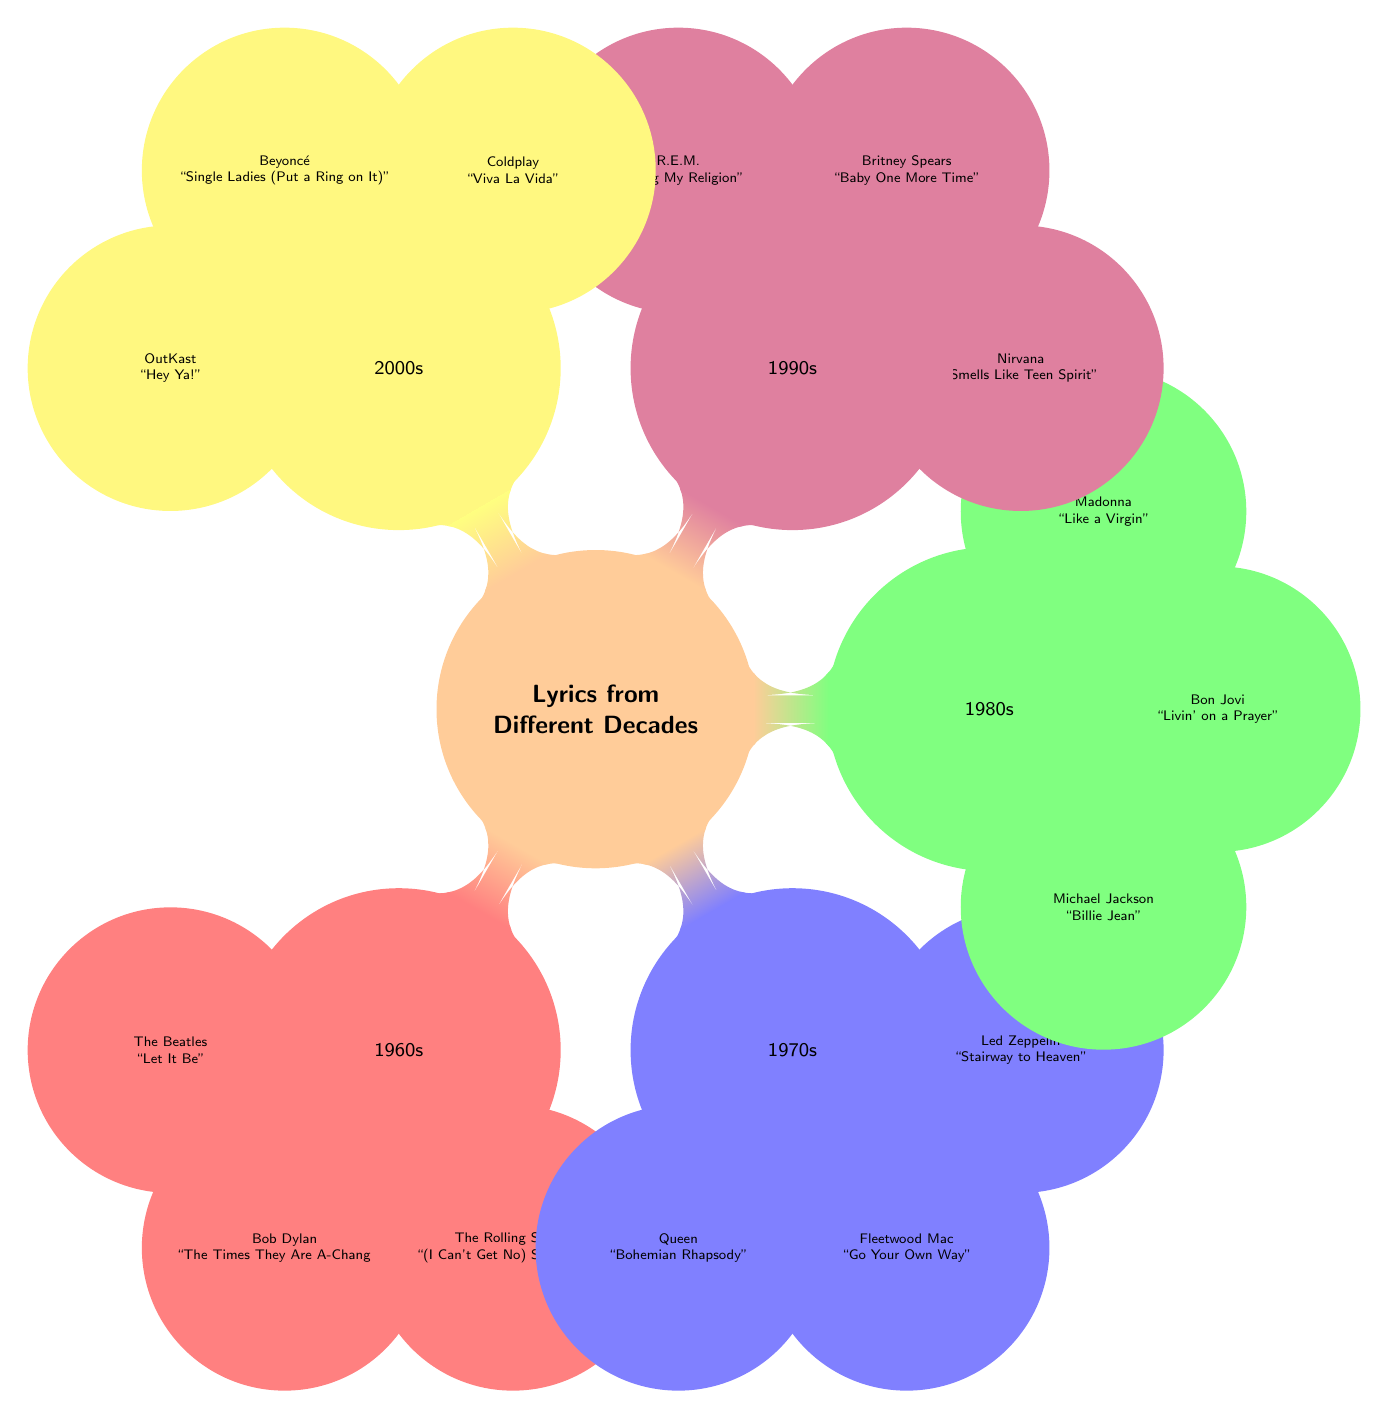What decade features "Billie Jean" by Michael Jackson? The diagram indicates that "Billie Jean" by Michael Jackson is located under the 1980s node. Therefore, the answer corresponds to that decade.
Answer: 1980s Which song by The Beatles is mentioned? The diagram lists “Let It Be” as the song by The Beatles under the 1960s node. Therefore, it directly identifies the song referenced.
Answer: Let It Be How many songs are listed under the 1990s? By counting the child nodes under the 1990s node in the diagram, we see there are three songs listed. Thus, the answer reflects this count.
Answer: 3 What genre does "Hey Ya!" belong to? "Hey Ya!" is listed as one of the songs under the 2000s node. While the diagram does not explicitly state the genre, it is widely known as a hip-hop song, which is inferred from the categorical grouping.
Answer: Hip-hop Which song includes the lyric "If you liked it, then you shoulda put a ring on it"? The diagram indicates that this lyric comes from Beyoncé's song "Single Ladies (Put a Ring on It)" listed under the 2000s node. Therefore, the song title can be directly traced to the lyric mentioned.
Answer: Single Ladies (Put a Ring on It) What is the common theme of the songs listed in the 1970s? While the diagram does not explicitly outline a common theme, by reviewing the song titles and understanding the cultural context of the era, we can deduce that the theme tends to revolve around personal and emotional experiences, typical of the 1970s music.
Answer: Personal and emotional experiences Which decade has "Smells Like Teen Spirit"? From the diagram, "Smells Like Teen Spirit" is identified under the 1990s node, directing us to the specific decade associated with the song.
Answer: 1990s How many decades are represented in the diagram? The diagram displays five distinct decades, each represented as a top-level node. Thus, the answer reflects the number of decades shown in the mind map.
Answer: 5 Which artist is associated with "Stairway to Heaven"? The diagram directly connects "Stairway to Heaven" with Led Zeppelin, indicated under the 1970s node. Therefore, the artist associated can be easily identified from the visual information presented.
Answer: Led Zeppelin 